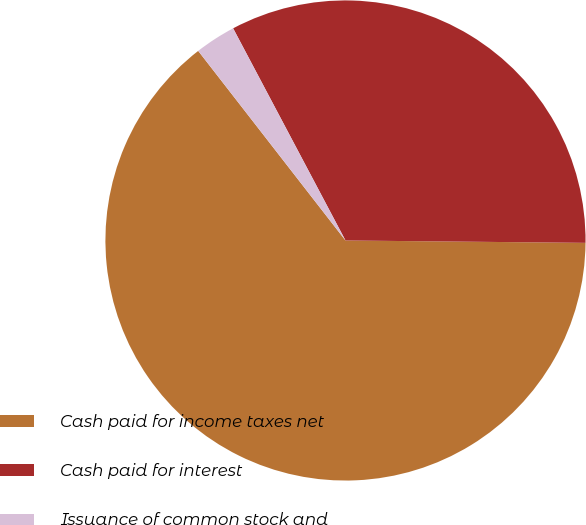Convert chart to OTSL. <chart><loc_0><loc_0><loc_500><loc_500><pie_chart><fcel>Cash paid for income taxes net<fcel>Cash paid for interest<fcel>Issuance of common stock and<nl><fcel>64.33%<fcel>32.91%<fcel>2.76%<nl></chart> 